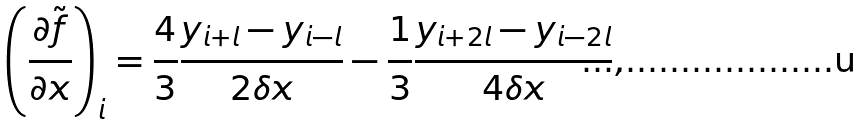<formula> <loc_0><loc_0><loc_500><loc_500>\left ( \frac { \partial \tilde { f } } { \partial x } \right ) _ { i } = \frac { 4 } { 3 } \frac { y _ { i + l } - y _ { i - l } } { 2 \delta x } - \frac { 1 } { 3 } \frac { y _ { i + 2 l } - y _ { i - 2 l } } { 4 \delta x } ,</formula> 